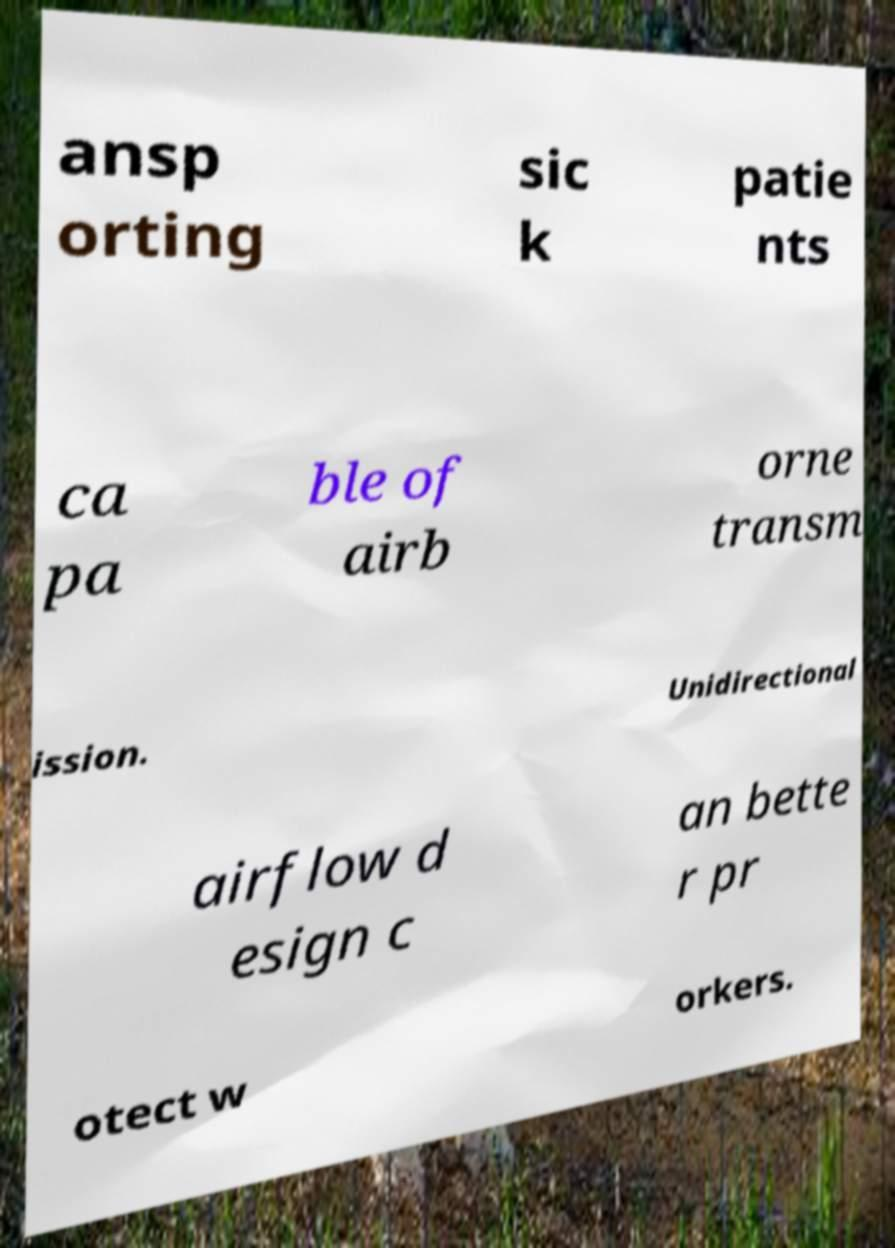Can you accurately transcribe the text from the provided image for me? ansp orting sic k patie nts ca pa ble of airb orne transm ission. Unidirectional airflow d esign c an bette r pr otect w orkers. 